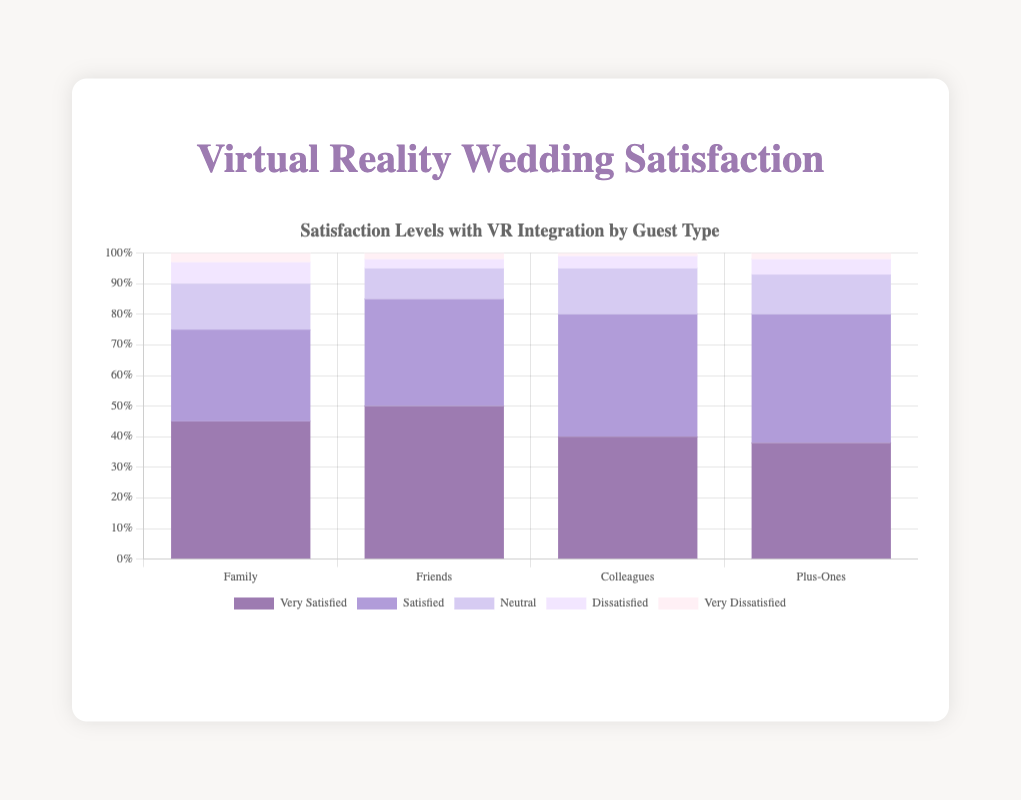How many more very satisfied guests are there among Friends compared to Plus-Ones? To find the difference in the number of very satisfied guests, we subtract the number of very satisfied Plus-Ones from the number of very satisfied Friends: 50 (Friends) - 38 (Plus-Ones) = 12
Answer: 12 Which guest type has the highest percentage of dissatisfied guests? By looking at the dissatisfaction levels across each guest type, we see that Family has 7%, Friends have 3%, Colleagues have 4%, and Plus-Ones have 5%. Family has the highest percentage at 7%.
Answer: Family What is the total percentage of guests who are either neutral or dissatisfied among Colleagues? Adding the percentages of neutral and dissatisfied guests for Colleagues: 15% (neutral) + 4% (dissatisfied) = 19%
Answer: 19% Which satisfaction level has the smallest percentage for all guest types? By comparing the percentages of all satisfaction levels across all guest types, the very dissatisfied level consistently has the smallest percentages: Family (3%), Friends (2%), Colleagues (1%), and Plus-Ones (2%).
Answer: Very Dissatisfied Which guest type has the highest percentage of guests satisfied with the VR integration? By comparing the satisfaction levels of satisfied guests, Plus-Ones have the highest percentage at 42%, higher than Family (30%), Friends (35%), and Colleagues (40%).
Answer: Plus-Ones What is the sum of very satisfied and satisfied guests among Family? Adding the percentages of very satisfied and satisfied guests for Family: 45% (very satisfied) + 30% (satisfied) = 75%
Answer: 75% What percentage of Family guests are more satisfied (very satisfied + satisfied) compared to Friends? To find the difference in satisfied guests: (45%+30%) - (50%+35%) = 75% - 85% = -10%. Therefore, Family guests are 10% less satisfied compared to Friends.
Answer: -10% Which guest type has the same percentage for very dissatisfied and neutral guests? Look at the percentages for very dissatisfied and neutral across all guest types. For Colleagues, the percentages are 15% (neutral) and 1% (very dissatisfied), and no guest type has the same percentage for very dissatisfied and neutral guests.
Answer: None 